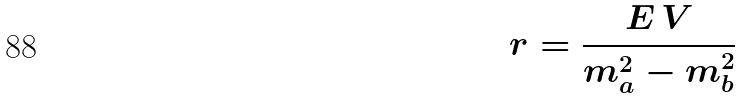Convert formula to latex. <formula><loc_0><loc_0><loc_500><loc_500>r = \frac { E \, V } { m _ { a } ^ { 2 } - m _ { b } ^ { 2 } }</formula> 